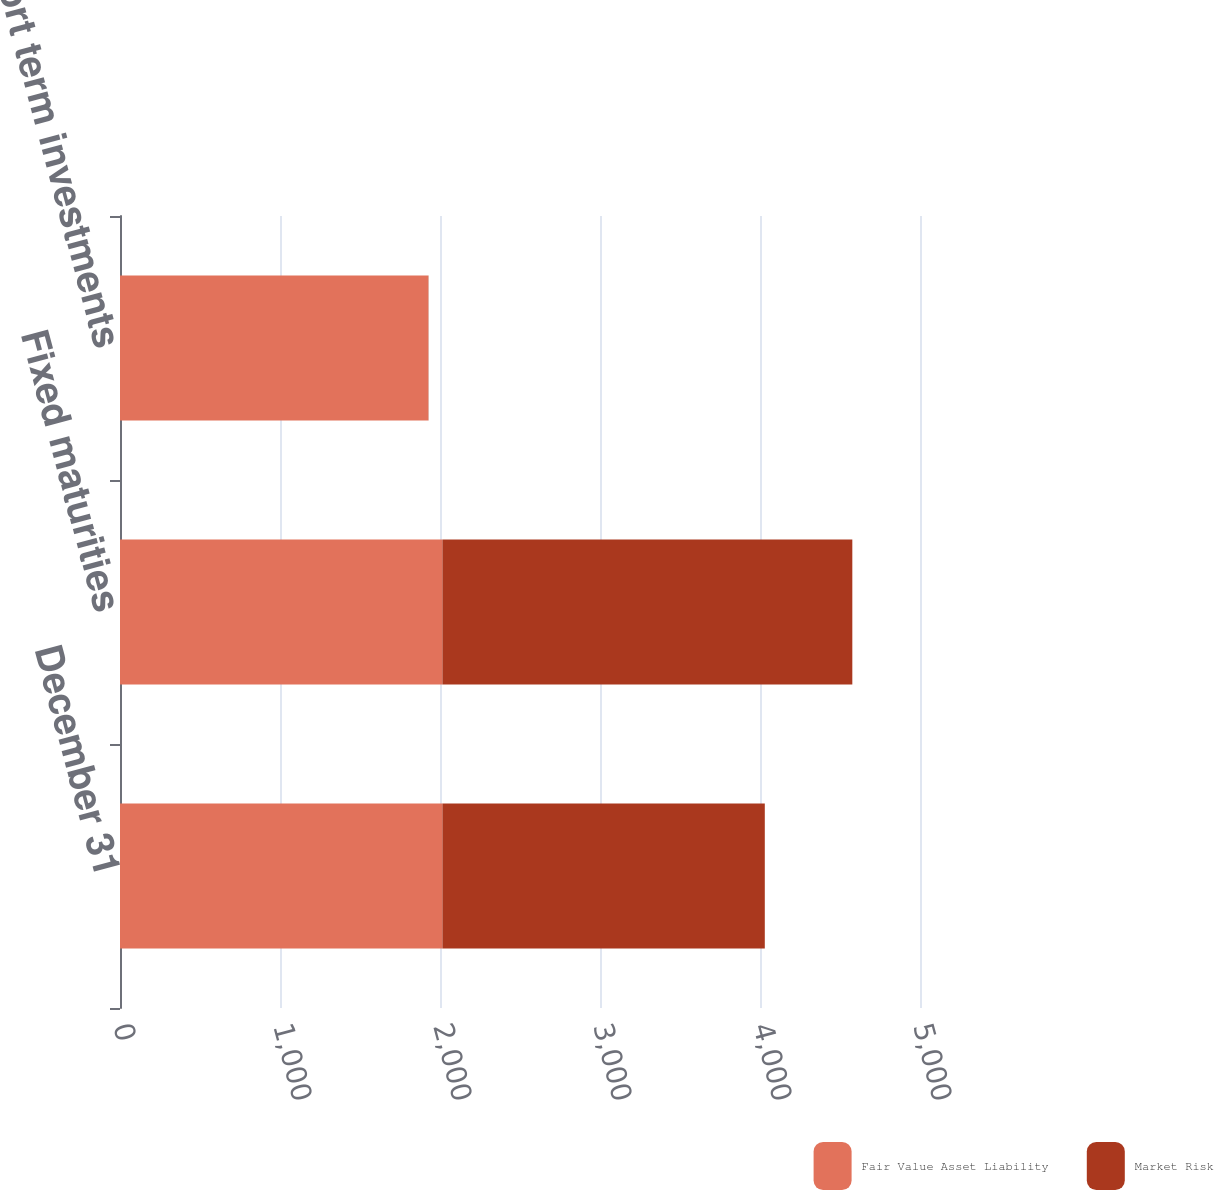Convert chart to OTSL. <chart><loc_0><loc_0><loc_500><loc_500><stacked_bar_chart><ecel><fcel>December 31<fcel>Fixed maturities<fcel>(a) Short term investments<nl><fcel>Fair Value Asset Liability<fcel>2015<fcel>2015<fcel>1926<nl><fcel>Market Risk<fcel>2015<fcel>2562<fcel>2<nl></chart> 